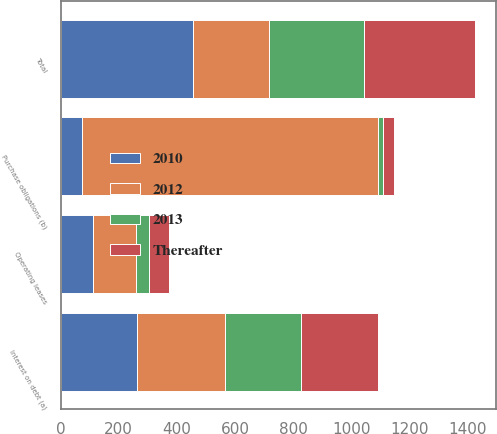Convert chart to OTSL. <chart><loc_0><loc_0><loc_500><loc_500><stacked_bar_chart><ecel><fcel>Interest on debt (a)<fcel>Operating leases<fcel>Purchase obligations (b)<fcel>Total<nl><fcel>2012<fcel>304<fcel>149<fcel>1022<fcel>262<nl><fcel>2010<fcel>263<fcel>112<fcel>72<fcel>456<nl><fcel>Thereafter<fcel>263<fcel>70<fcel>39<fcel>381<nl><fcel>2013<fcel>262<fcel>42<fcel>15<fcel>328<nl></chart> 